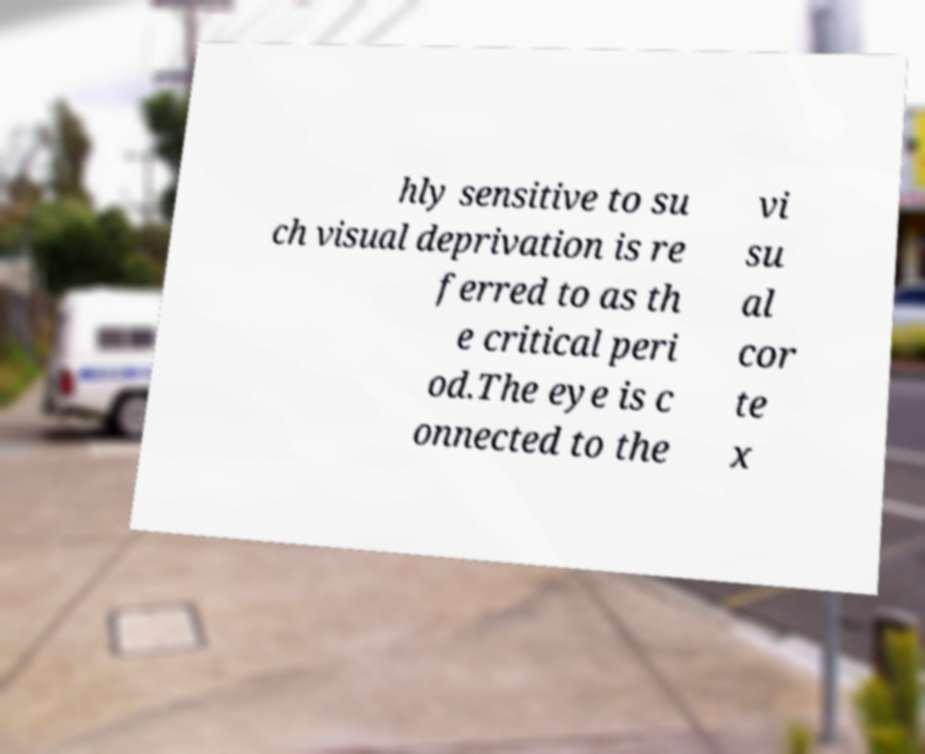Can you read and provide the text displayed in the image?This photo seems to have some interesting text. Can you extract and type it out for me? hly sensitive to su ch visual deprivation is re ferred to as th e critical peri od.The eye is c onnected to the vi su al cor te x 